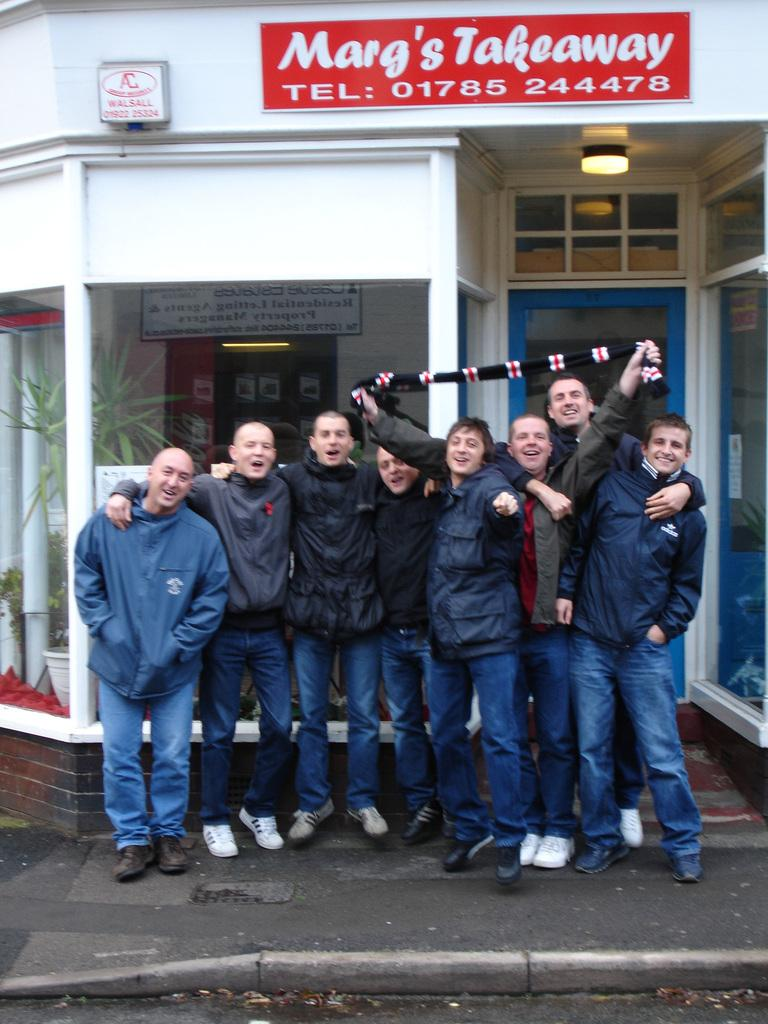How many people are in the image? There is a group of people in the image, but the exact number cannot be determined from the provided facts. What is the position of the people in the image? The people are on the ground in the image. What can be seen in the background of the image? In the background of the image, there are plants, boards, a light, and a door. Can you describe the setting of the image? The image appears to be set outdoors, given the presence of plants and a door in the background. What type of disgust can be seen on the faces of the people in the image? There is no indication of any emotion, including disgust, on the faces of the people in the image. What type of bag is being used by the people in the image? There is no bag present in the image. 